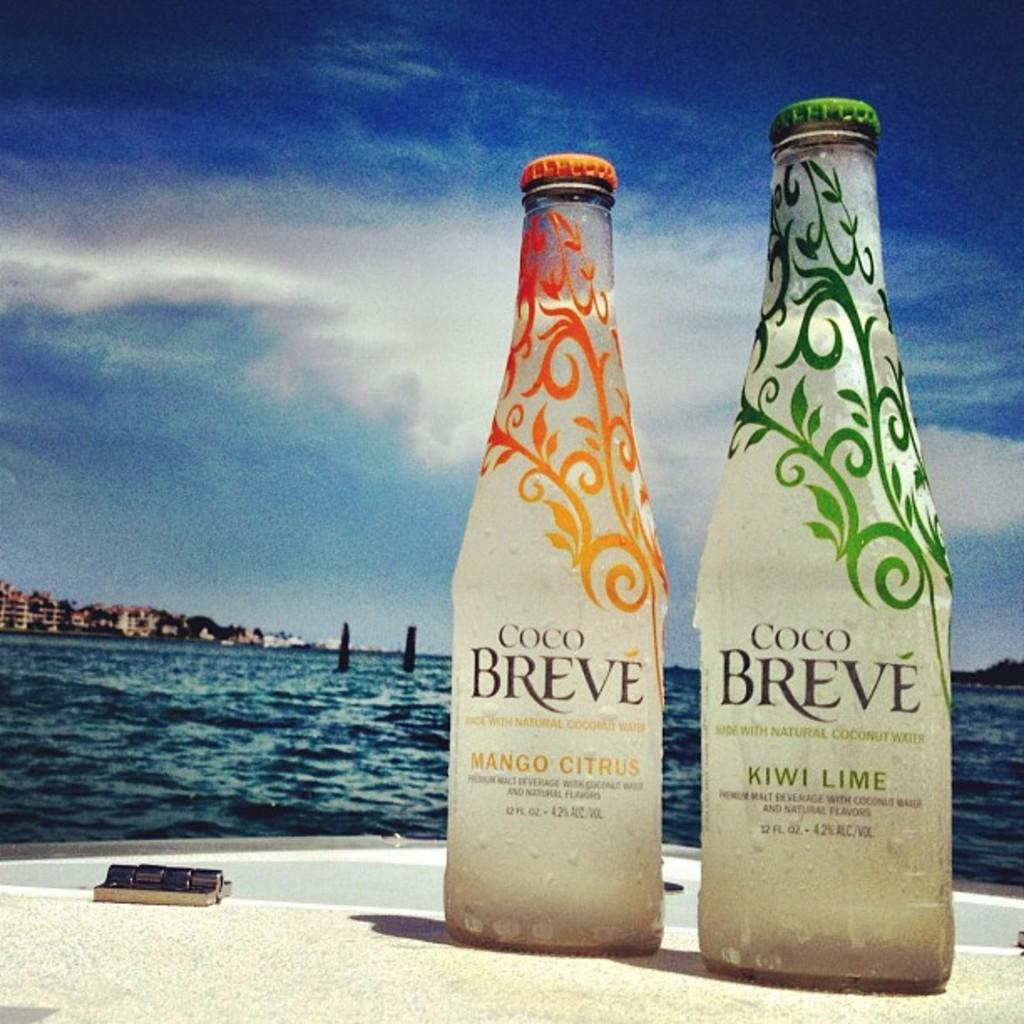Provide a one-sentence caption for the provided image. Two bottles of Coco Breve on a boat in the water. 